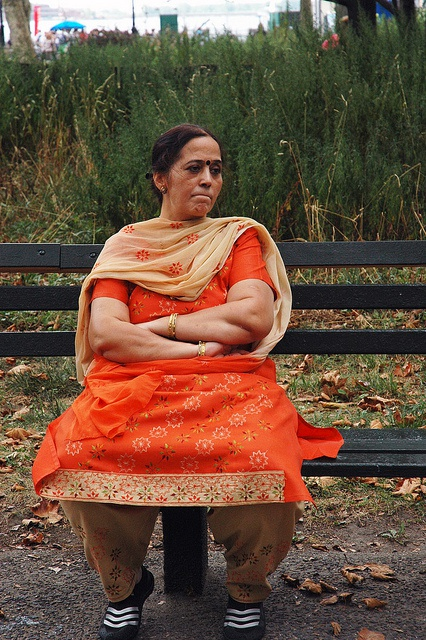Describe the objects in this image and their specific colors. I can see people in purple, red, maroon, and black tones, bench in purple, black, olive, gray, and maroon tones, and umbrella in purple, lightblue, and white tones in this image. 